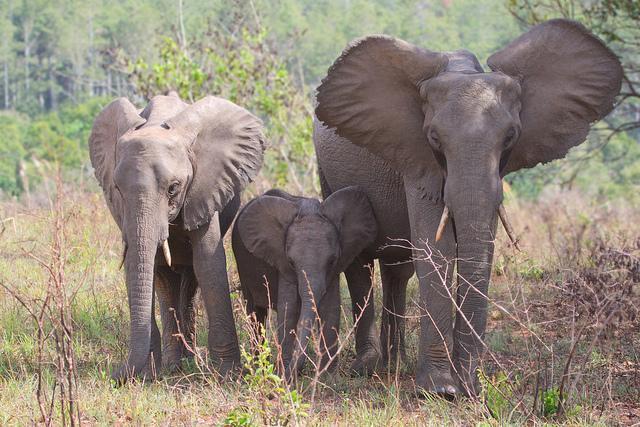How many elephants?
Give a very brief answer. 3. How many elephants are in the picture?
Give a very brief answer. 3. 